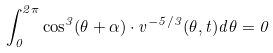<formula> <loc_0><loc_0><loc_500><loc_500>\int _ { 0 } ^ { 2 \pi } \cos ^ { 3 } ( \theta + \alpha ) \cdot v ^ { - 5 / 3 } ( \theta , t ) d \theta = 0</formula> 